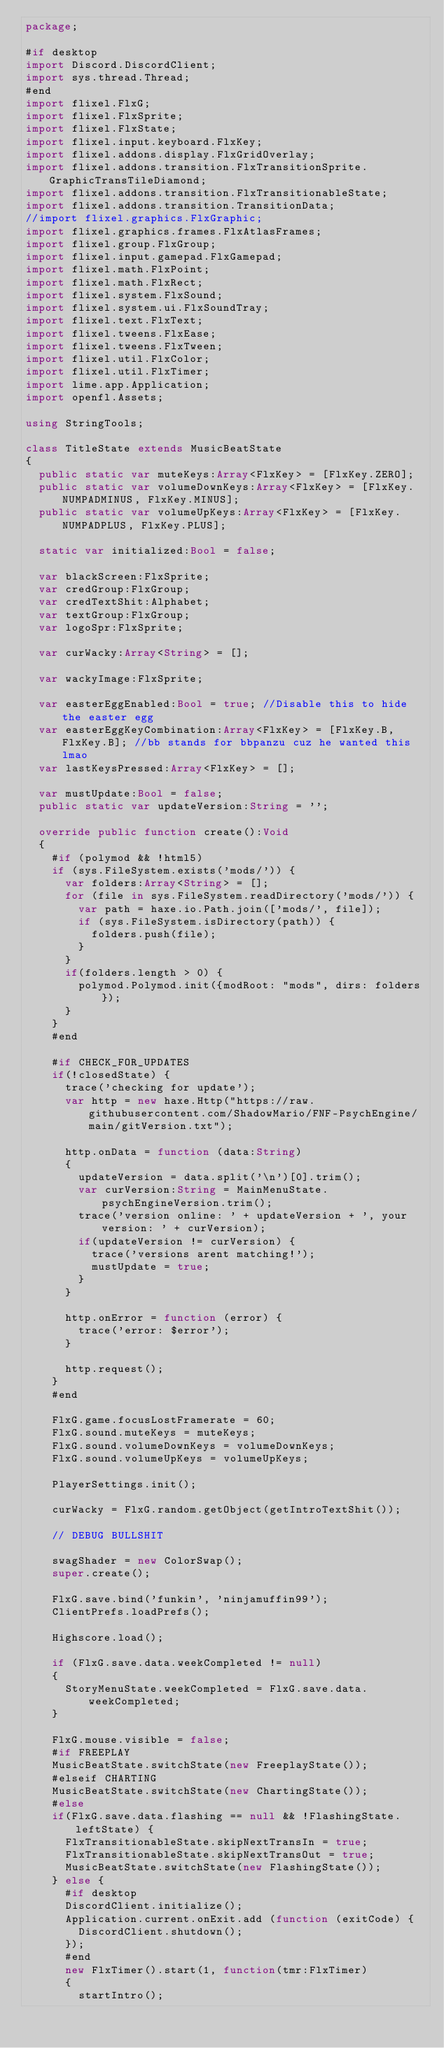Convert code to text. <code><loc_0><loc_0><loc_500><loc_500><_Haxe_>package;

#if desktop
import Discord.DiscordClient;
import sys.thread.Thread;
#end
import flixel.FlxG;
import flixel.FlxSprite;
import flixel.FlxState;
import flixel.input.keyboard.FlxKey;
import flixel.addons.display.FlxGridOverlay;
import flixel.addons.transition.FlxTransitionSprite.GraphicTransTileDiamond;
import flixel.addons.transition.FlxTransitionableState;
import flixel.addons.transition.TransitionData;
//import flixel.graphics.FlxGraphic;
import flixel.graphics.frames.FlxAtlasFrames;
import flixel.group.FlxGroup;
import flixel.input.gamepad.FlxGamepad;
import flixel.math.FlxPoint;
import flixel.math.FlxRect;
import flixel.system.FlxSound;
import flixel.system.ui.FlxSoundTray;
import flixel.text.FlxText;
import flixel.tweens.FlxEase;
import flixel.tweens.FlxTween;
import flixel.util.FlxColor;
import flixel.util.FlxTimer;
import lime.app.Application;
import openfl.Assets;

using StringTools;

class TitleState extends MusicBeatState
{
	public static var muteKeys:Array<FlxKey> = [FlxKey.ZERO];
	public static var volumeDownKeys:Array<FlxKey> = [FlxKey.NUMPADMINUS, FlxKey.MINUS];
	public static var volumeUpKeys:Array<FlxKey> = [FlxKey.NUMPADPLUS, FlxKey.PLUS];

	static var initialized:Bool = false;

	var blackScreen:FlxSprite;
	var credGroup:FlxGroup;
	var credTextShit:Alphabet;
	var textGroup:FlxGroup;
	var logoSpr:FlxSprite;

	var curWacky:Array<String> = [];

	var wackyImage:FlxSprite;

	var easterEggEnabled:Bool = true; //Disable this to hide the easter egg
	var easterEggKeyCombination:Array<FlxKey> = [FlxKey.B, FlxKey.B]; //bb stands for bbpanzu cuz he wanted this lmao
	var lastKeysPressed:Array<FlxKey> = [];

	var mustUpdate:Bool = false;
	public static var updateVersion:String = '';

	override public function create():Void
	{
		#if (polymod && !html5)
		if (sys.FileSystem.exists('mods/')) {
			var folders:Array<String> = [];
			for (file in sys.FileSystem.readDirectory('mods/')) {
				var path = haxe.io.Path.join(['mods/', file]);
				if (sys.FileSystem.isDirectory(path)) {
					folders.push(file);
				}
			}
			if(folders.length > 0) {
				polymod.Polymod.init({modRoot: "mods", dirs: folders});
			}
		}
		#end
		
		#if CHECK_FOR_UPDATES
		if(!closedState) {
			trace('checking for update');
			var http = new haxe.Http("https://raw.githubusercontent.com/ShadowMario/FNF-PsychEngine/main/gitVersion.txt");
			
			http.onData = function (data:String)
			{
				updateVersion = data.split('\n')[0].trim();
				var curVersion:String = MainMenuState.psychEngineVersion.trim();
				trace('version online: ' + updateVersion + ', your version: ' + curVersion);
				if(updateVersion != curVersion) {
					trace('versions arent matching!');
					mustUpdate = true;
				}
			}
			
			http.onError = function (error) {
				trace('error: $error');
			}
			
			http.request();
		}
		#end

		FlxG.game.focusLostFramerate = 60;
		FlxG.sound.muteKeys = muteKeys;
		FlxG.sound.volumeDownKeys = volumeDownKeys;
		FlxG.sound.volumeUpKeys = volumeUpKeys;

		PlayerSettings.init();

		curWacky = FlxG.random.getObject(getIntroTextShit());

		// DEBUG BULLSHIT

		swagShader = new ColorSwap();
		super.create();

		FlxG.save.bind('funkin', 'ninjamuffin99');
		ClientPrefs.loadPrefs();

		Highscore.load();

		if (FlxG.save.data.weekCompleted != null)
		{
			StoryMenuState.weekCompleted = FlxG.save.data.weekCompleted;
		}

		FlxG.mouse.visible = false;
		#if FREEPLAY
		MusicBeatState.switchState(new FreeplayState());
		#elseif CHARTING
		MusicBeatState.switchState(new ChartingState());
		#else
		if(FlxG.save.data.flashing == null && !FlashingState.leftState) {
			FlxTransitionableState.skipNextTransIn = true;
			FlxTransitionableState.skipNextTransOut = true;
			MusicBeatState.switchState(new FlashingState());
		} else {
			#if desktop
			DiscordClient.initialize();
			Application.current.onExit.add (function (exitCode) {
				DiscordClient.shutdown();
			});
			#end
			new FlxTimer().start(1, function(tmr:FlxTimer)
			{
				startIntro();</code> 